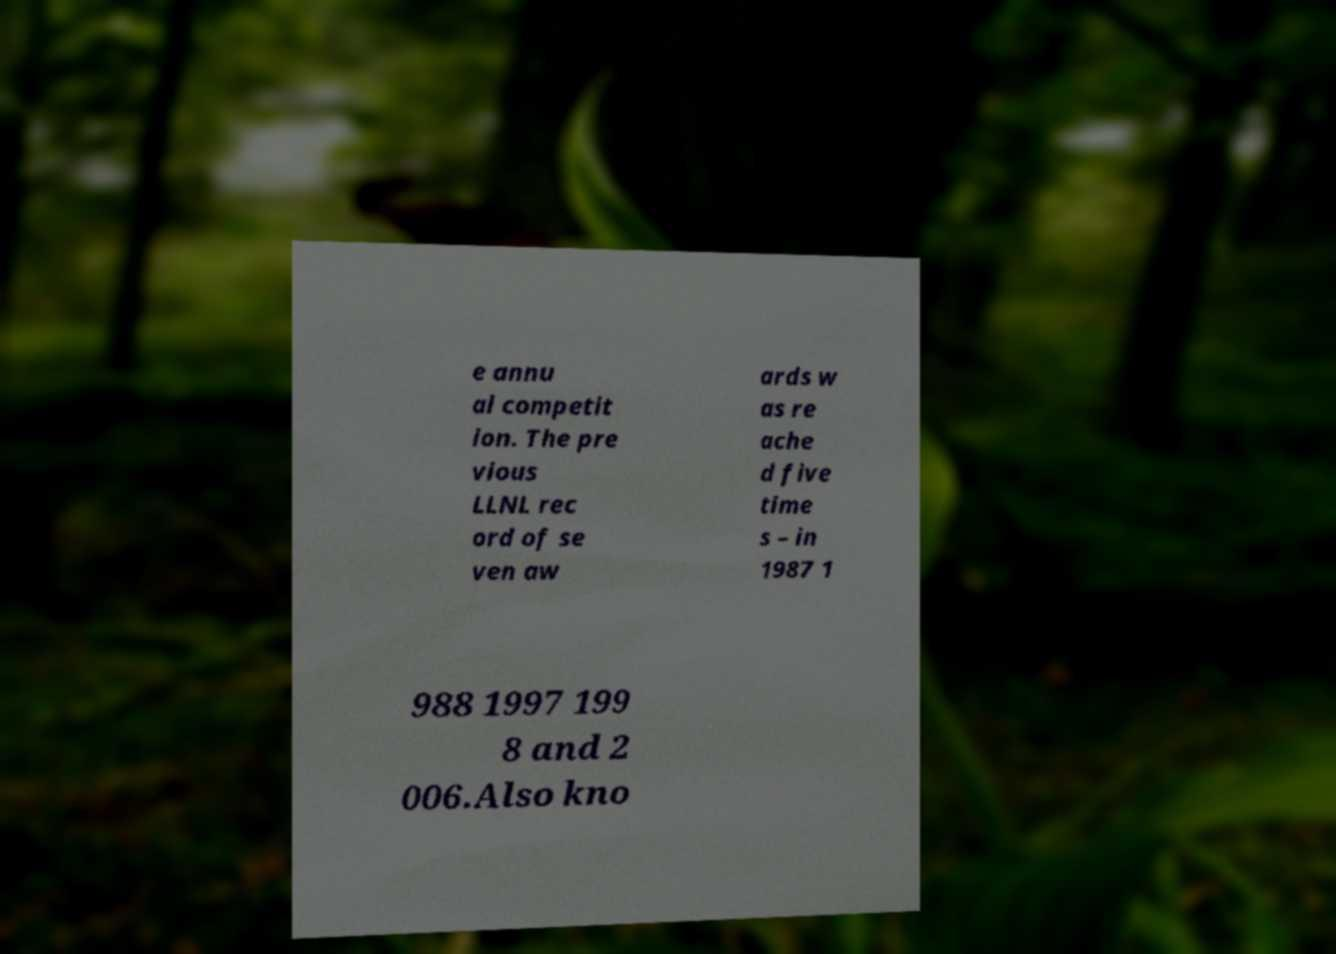There's text embedded in this image that I need extracted. Can you transcribe it verbatim? e annu al competit ion. The pre vious LLNL rec ord of se ven aw ards w as re ache d five time s – in 1987 1 988 1997 199 8 and 2 006.Also kno 